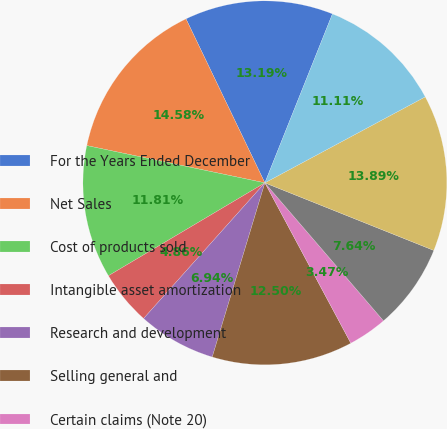<chart> <loc_0><loc_0><loc_500><loc_500><pie_chart><fcel>For the Years Ended December<fcel>Net Sales<fcel>Cost of products sold<fcel>Intangible asset amortization<fcel>Research and development<fcel>Selling general and<fcel>Certain claims (Note 20)<fcel>Special items (Note 3)<fcel>Operating expenses<fcel>Operating Profit<nl><fcel>13.19%<fcel>14.58%<fcel>11.81%<fcel>4.86%<fcel>6.94%<fcel>12.5%<fcel>3.47%<fcel>7.64%<fcel>13.89%<fcel>11.11%<nl></chart> 